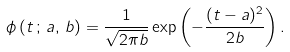<formula> <loc_0><loc_0><loc_500><loc_500>\phi \left ( t \, ; \, a , \, b \right ) = \frac { 1 } { \sqrt { 2 \pi b } } \exp \left ( - \frac { ( t - a ) ^ { 2 } } { 2 b } \right ) .</formula> 